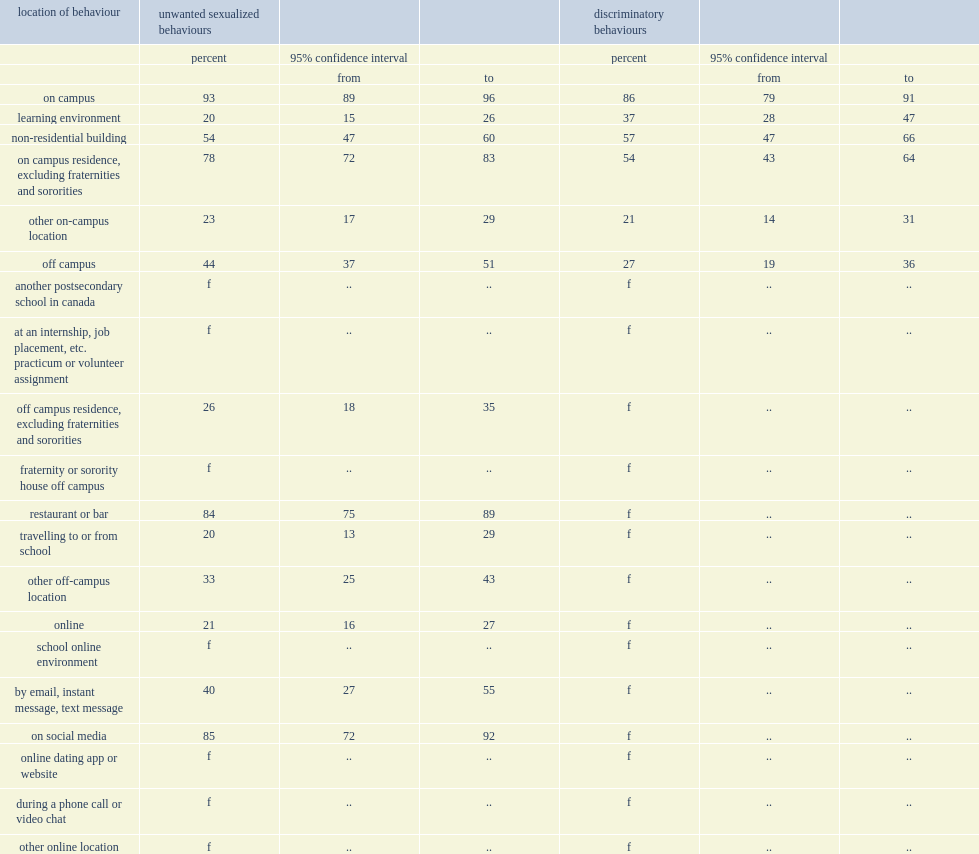What was the percent of those who experienced them on campus indicated that they happened in an on-campus residence? 78.0. What was the proportion of unwanted sexualized behaviours on campus occurred in a non-residential building (such as a library, cafeteria or gym)? 54.0. What was the propotion of most behaviours that occurred online happened on social media? 85.0. 